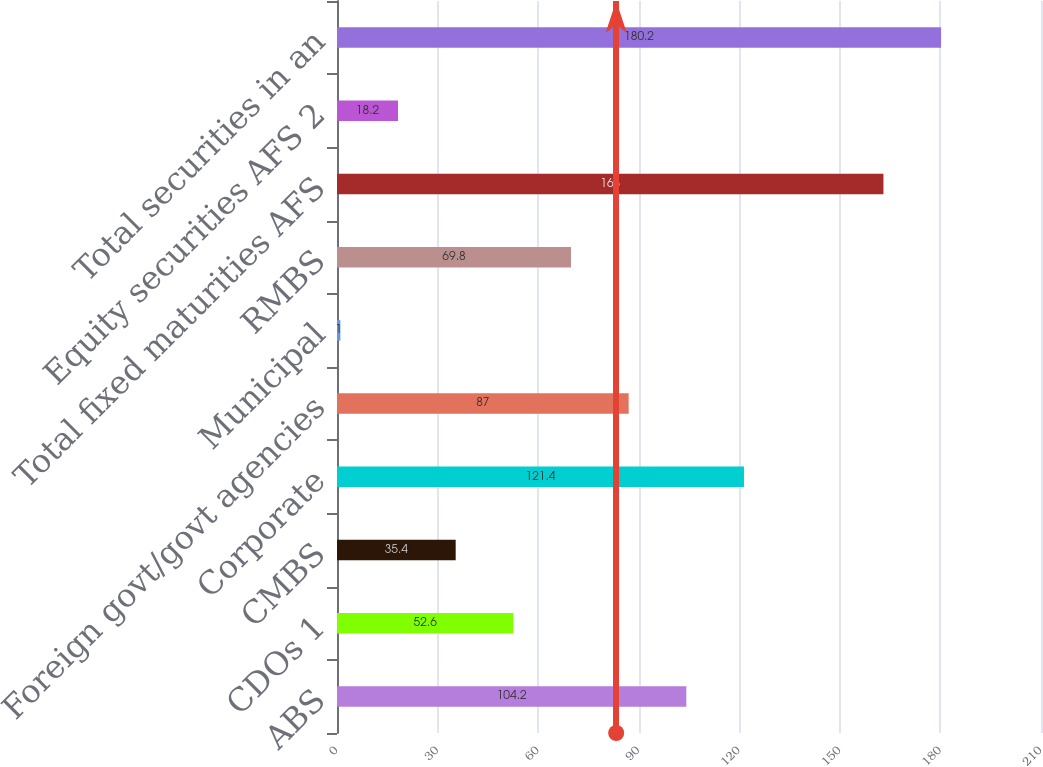<chart> <loc_0><loc_0><loc_500><loc_500><bar_chart><fcel>ABS<fcel>CDOs 1<fcel>CMBS<fcel>Corporate<fcel>Foreign govt/govt agencies<fcel>Municipal<fcel>RMBS<fcel>Total fixed maturities AFS<fcel>Equity securities AFS 2<fcel>Total securities in an<nl><fcel>104.2<fcel>52.6<fcel>35.4<fcel>121.4<fcel>87<fcel>1<fcel>69.8<fcel>163<fcel>18.2<fcel>180.2<nl></chart> 